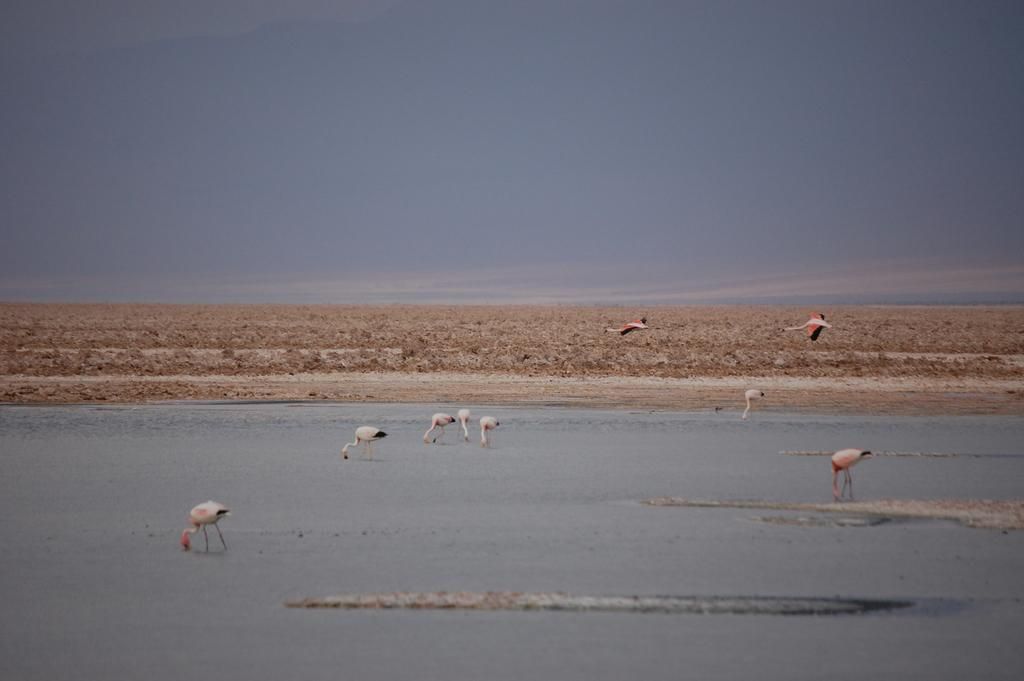What type of large birds are present in the image? There are cranes in the image. What natural element can be seen alongside the cranes? There is water visible in the image. What type of vegetation is present in the image? There are plants in the image. How would you describe the sky in the image? The sky is blue and cloudy in the image. Where is the playground located in the image? There is no playground present in the image. What type of cooking equipment can be seen in the image? There is no cooking equipment present in the image. 